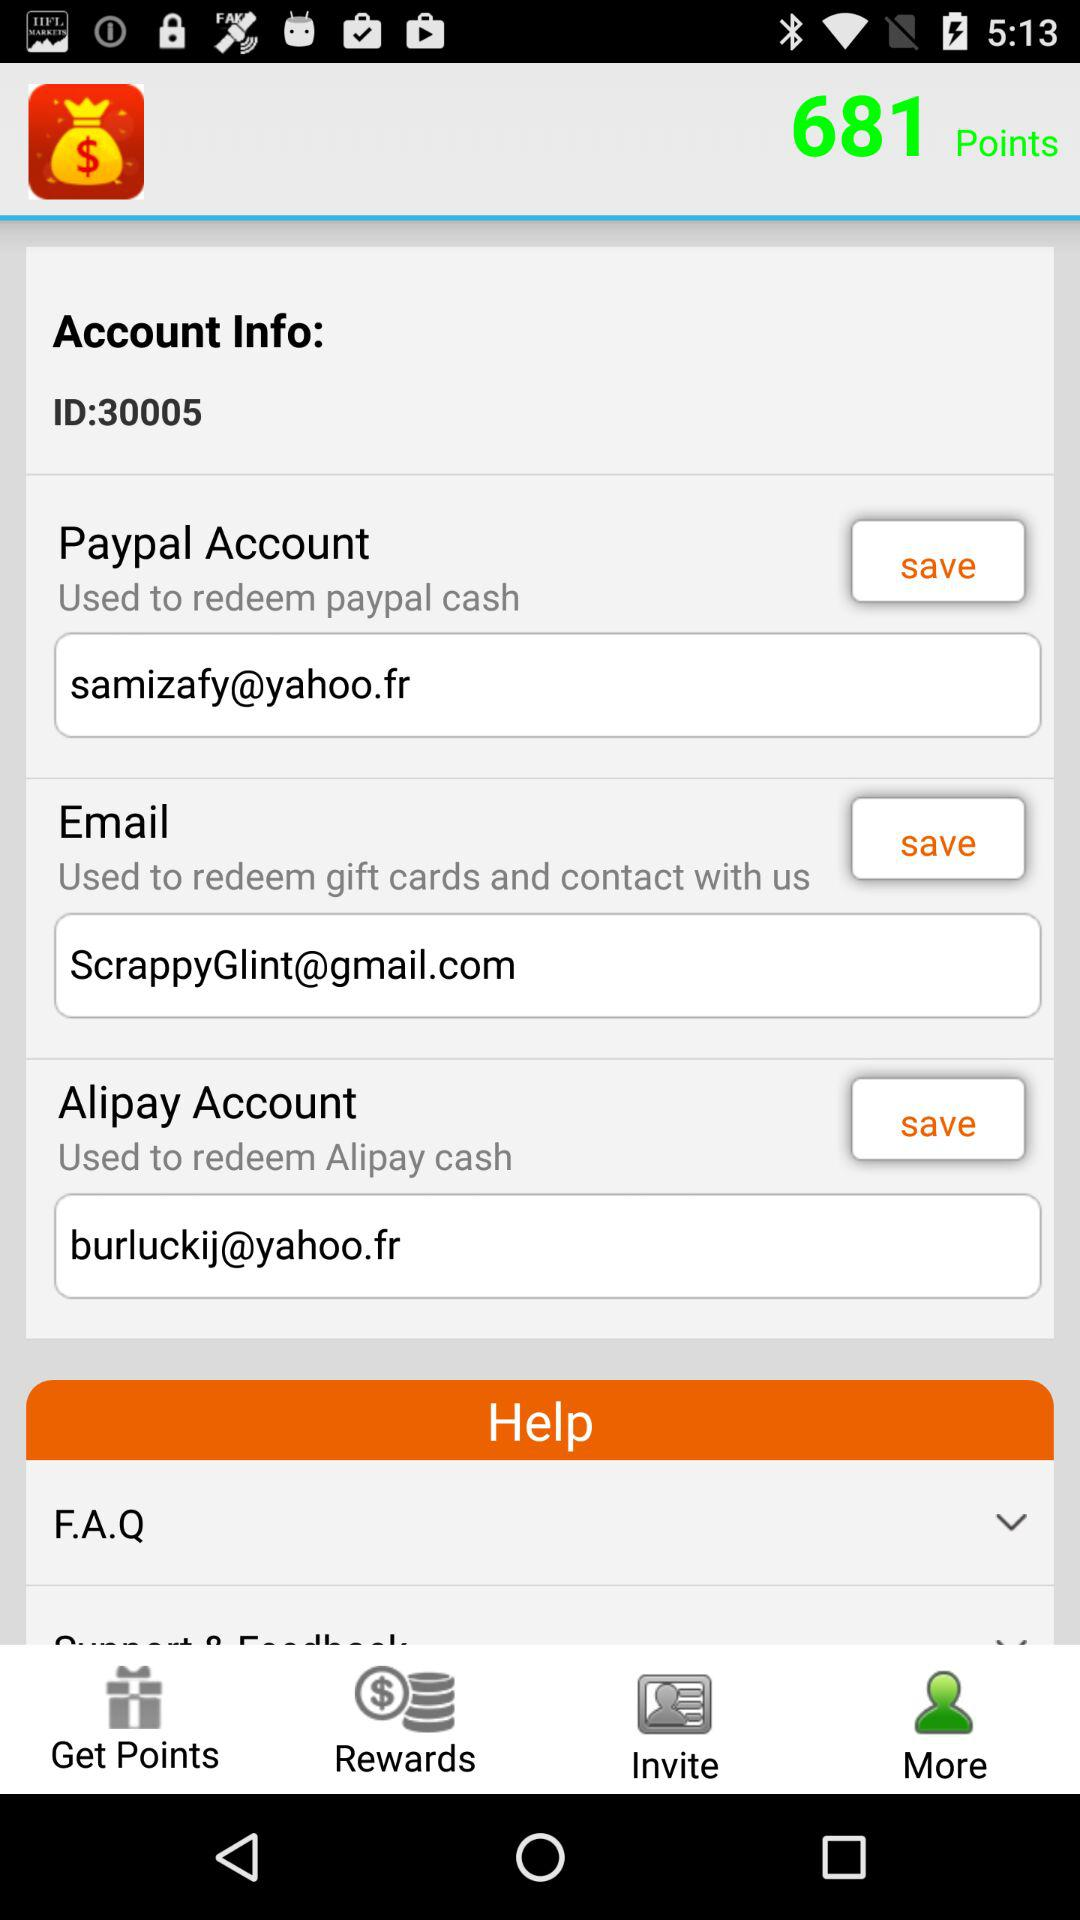Which tab has been selected? The selected tab is "More". 